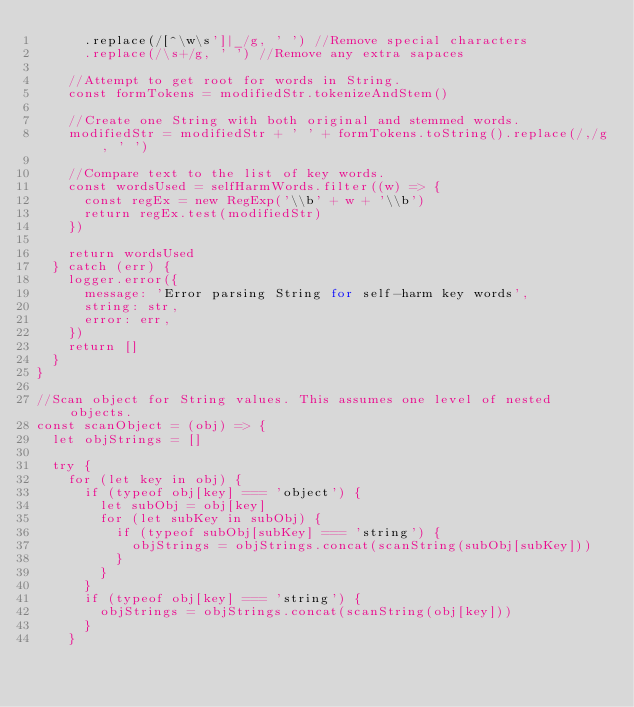Convert code to text. <code><loc_0><loc_0><loc_500><loc_500><_JavaScript_>      .replace(/[^\w\s']|_/g, ' ') //Remove special characters
      .replace(/\s+/g, ' ') //Remove any extra sapaces

    //Attempt to get root for words in String.
    const formTokens = modifiedStr.tokenizeAndStem()

    //Create one String with both original and stemmed words.
    modifiedStr = modifiedStr + ' ' + formTokens.toString().replace(/,/g, ' ')

    //Compare text to the list of key words.
    const wordsUsed = selfHarmWords.filter((w) => {
      const regEx = new RegExp('\\b' + w + '\\b')
      return regEx.test(modifiedStr)
    })

    return wordsUsed
  } catch (err) {
    logger.error({
      message: 'Error parsing String for self-harm key words',
      string: str,
      error: err,
    })
    return []
  }
}

//Scan object for String values. This assumes one level of nested objects.
const scanObject = (obj) => {
  let objStrings = []

  try {
    for (let key in obj) {
      if (typeof obj[key] === 'object') {
        let subObj = obj[key]
        for (let subKey in subObj) {
          if (typeof subObj[subKey] === 'string') {
            objStrings = objStrings.concat(scanString(subObj[subKey]))
          }
        }
      }
      if (typeof obj[key] === 'string') {
        objStrings = objStrings.concat(scanString(obj[key]))
      }
    }</code> 